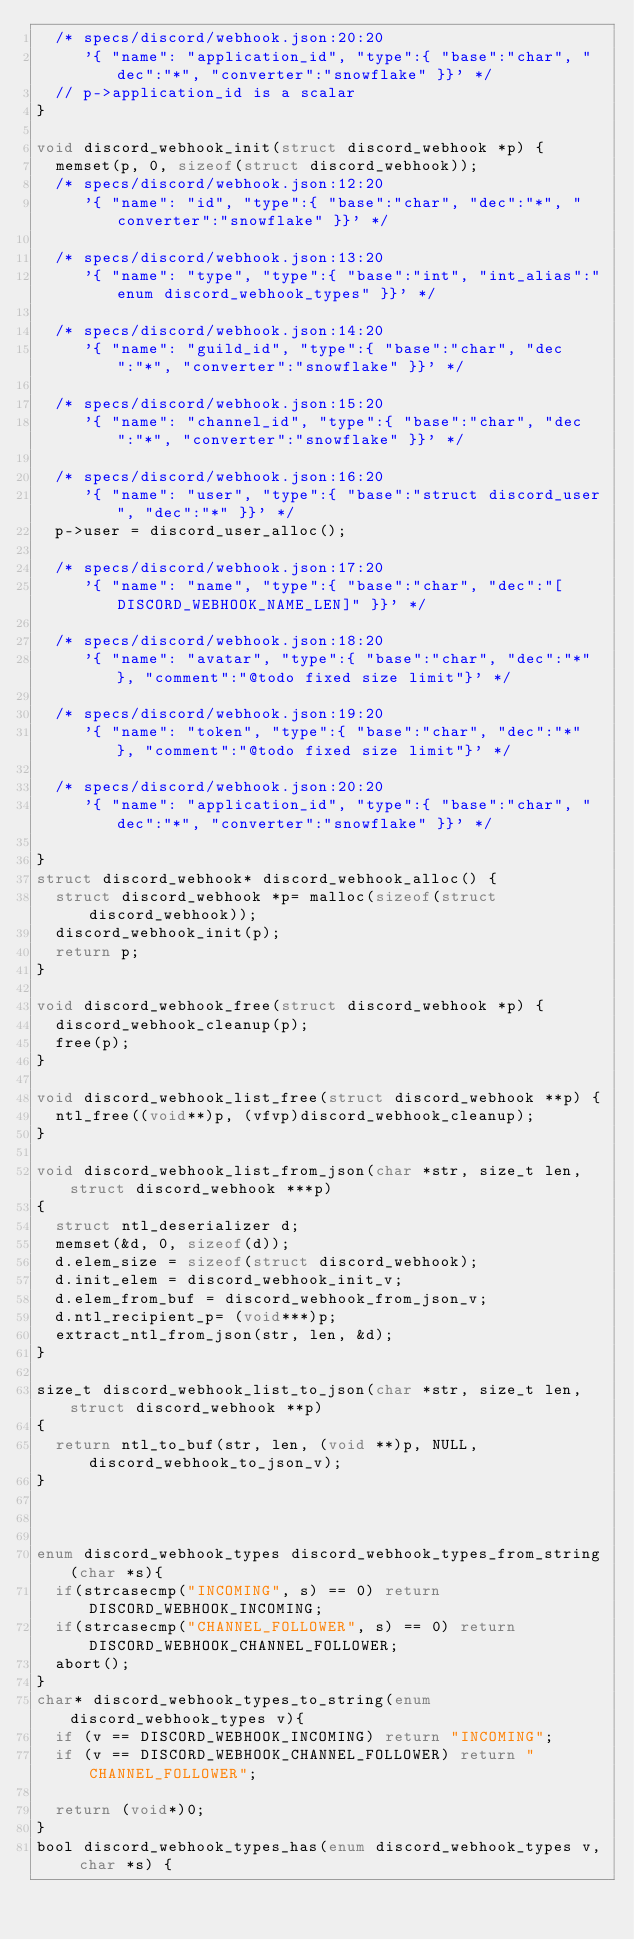<code> <loc_0><loc_0><loc_500><loc_500><_C_>  /* specs/discord/webhook.json:20:20
     '{ "name": "application_id", "type":{ "base":"char", "dec":"*", "converter":"snowflake" }}' */
  // p->application_id is a scalar
}

void discord_webhook_init(struct discord_webhook *p) {
  memset(p, 0, sizeof(struct discord_webhook));
  /* specs/discord/webhook.json:12:20
     '{ "name": "id", "type":{ "base":"char", "dec":"*", "converter":"snowflake" }}' */

  /* specs/discord/webhook.json:13:20
     '{ "name": "type", "type":{ "base":"int", "int_alias":"enum discord_webhook_types" }}' */

  /* specs/discord/webhook.json:14:20
     '{ "name": "guild_id", "type":{ "base":"char", "dec":"*", "converter":"snowflake" }}' */

  /* specs/discord/webhook.json:15:20
     '{ "name": "channel_id", "type":{ "base":"char", "dec":"*", "converter":"snowflake" }}' */

  /* specs/discord/webhook.json:16:20
     '{ "name": "user", "type":{ "base":"struct discord_user", "dec":"*" }}' */
  p->user = discord_user_alloc();

  /* specs/discord/webhook.json:17:20
     '{ "name": "name", "type":{ "base":"char", "dec":"[DISCORD_WEBHOOK_NAME_LEN]" }}' */

  /* specs/discord/webhook.json:18:20
     '{ "name": "avatar", "type":{ "base":"char", "dec":"*" }, "comment":"@todo fixed size limit"}' */

  /* specs/discord/webhook.json:19:20
     '{ "name": "token", "type":{ "base":"char", "dec":"*" }, "comment":"@todo fixed size limit"}' */

  /* specs/discord/webhook.json:20:20
     '{ "name": "application_id", "type":{ "base":"char", "dec":"*", "converter":"snowflake" }}' */

}
struct discord_webhook* discord_webhook_alloc() {
  struct discord_webhook *p= malloc(sizeof(struct discord_webhook));
  discord_webhook_init(p);
  return p;
}

void discord_webhook_free(struct discord_webhook *p) {
  discord_webhook_cleanup(p);
  free(p);
}

void discord_webhook_list_free(struct discord_webhook **p) {
  ntl_free((void**)p, (vfvp)discord_webhook_cleanup);
}

void discord_webhook_list_from_json(char *str, size_t len, struct discord_webhook ***p)
{
  struct ntl_deserializer d;
  memset(&d, 0, sizeof(d));
  d.elem_size = sizeof(struct discord_webhook);
  d.init_elem = discord_webhook_init_v;
  d.elem_from_buf = discord_webhook_from_json_v;
  d.ntl_recipient_p= (void***)p;
  extract_ntl_from_json(str, len, &d);
}

size_t discord_webhook_list_to_json(char *str, size_t len, struct discord_webhook **p)
{
  return ntl_to_buf(str, len, (void **)p, NULL, discord_webhook_to_json_v);
}



enum discord_webhook_types discord_webhook_types_from_string(char *s){
  if(strcasecmp("INCOMING", s) == 0) return DISCORD_WEBHOOK_INCOMING;
  if(strcasecmp("CHANNEL_FOLLOWER", s) == 0) return DISCORD_WEBHOOK_CHANNEL_FOLLOWER;
  abort();
}
char* discord_webhook_types_to_string(enum discord_webhook_types v){
  if (v == DISCORD_WEBHOOK_INCOMING) return "INCOMING";
  if (v == DISCORD_WEBHOOK_CHANNEL_FOLLOWER) return "CHANNEL_FOLLOWER";

  return (void*)0;
}
bool discord_webhook_types_has(enum discord_webhook_types v, char *s) {</code> 